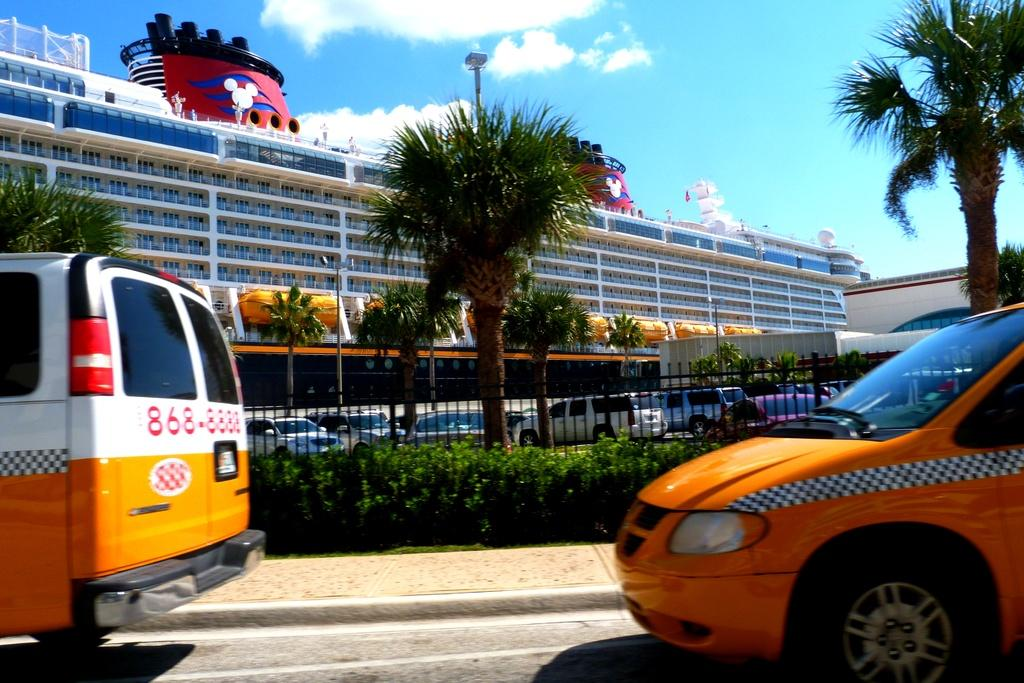<image>
Describe the image concisely. A yellow, white, and red van with number 868-8888 is parked close to a Disney cruise ship. 